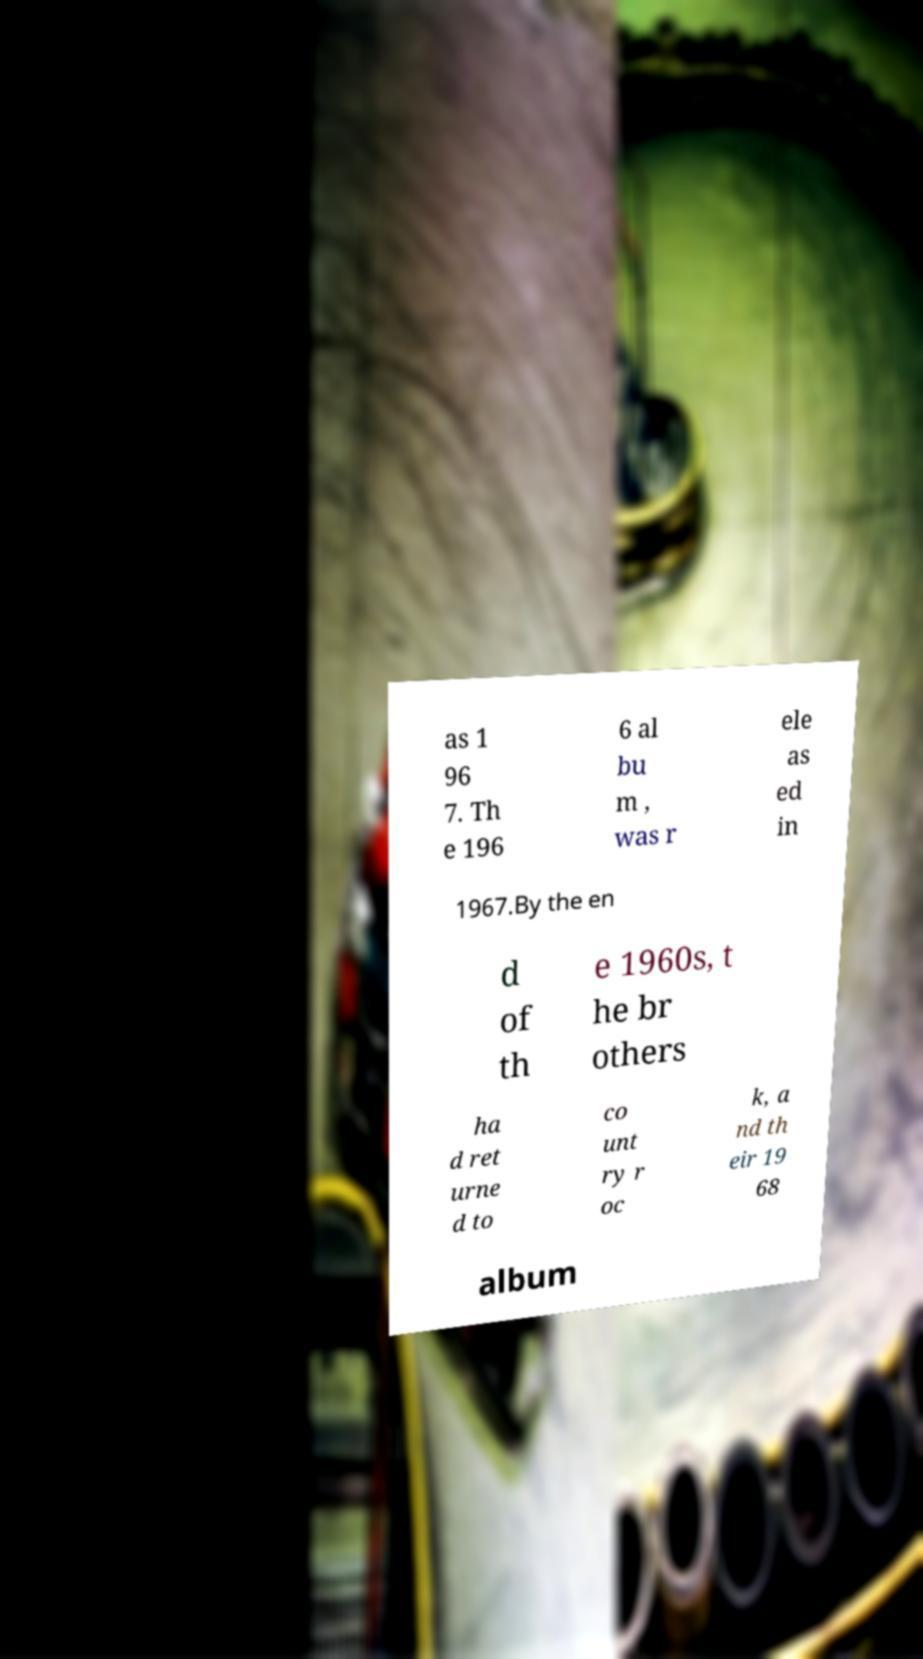There's text embedded in this image that I need extracted. Can you transcribe it verbatim? as 1 96 7. Th e 196 6 al bu m , was r ele as ed in 1967.By the en d of th e 1960s, t he br others ha d ret urne d to co unt ry r oc k, a nd th eir 19 68 album 